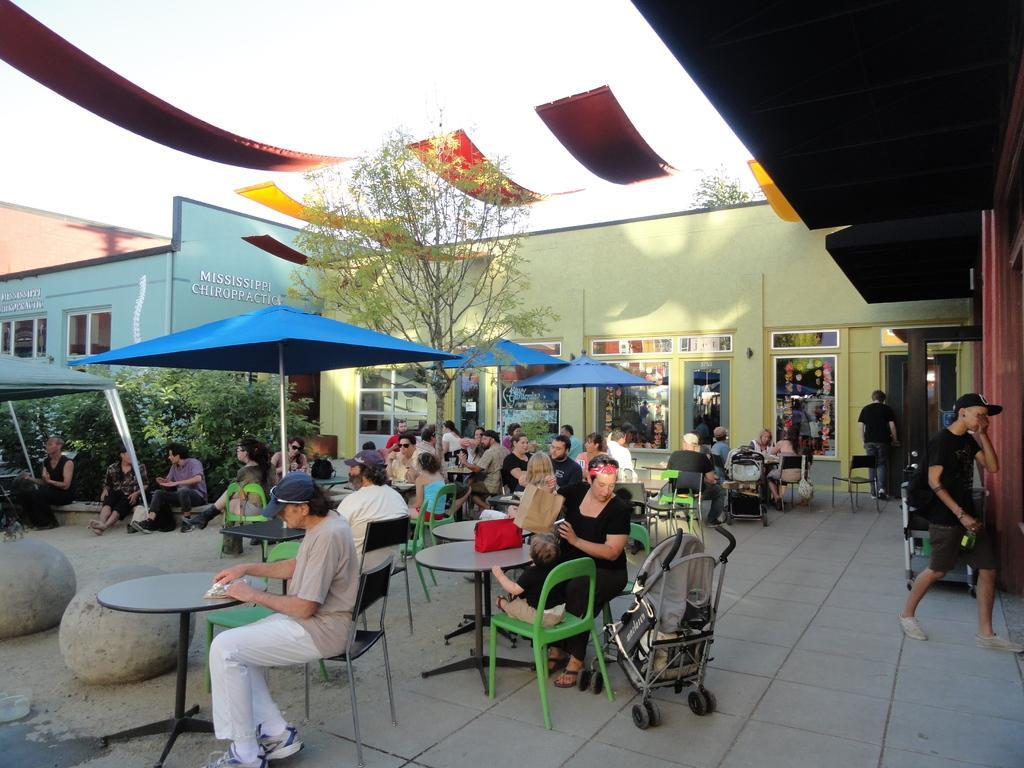How would you summarize this image in a sentence or two? There is a group of people. They are sitting on a chairs and two persons are standing. There is a table. There is a bag on a table. On the right side we have a person. He is walking and he is wearing a cap. We can see in background tent,building,plant,tree ,poster and banner. 